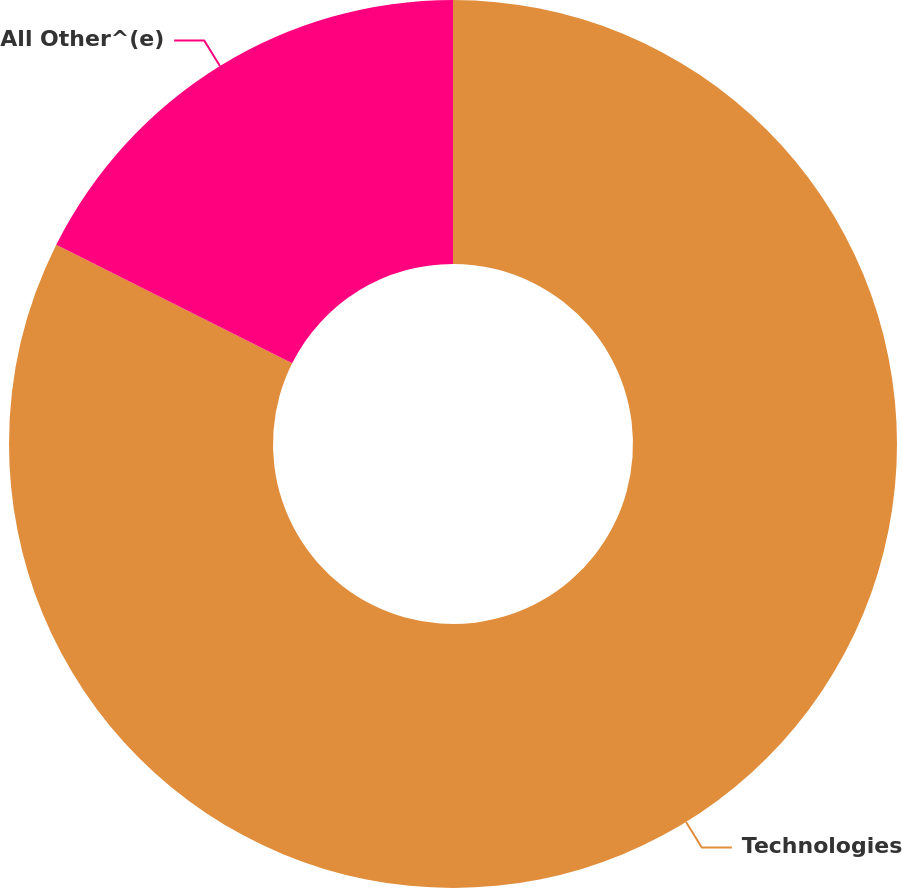Convert chart to OTSL. <chart><loc_0><loc_0><loc_500><loc_500><pie_chart><fcel>Technologies<fcel>All Other^(e)<nl><fcel>82.41%<fcel>17.59%<nl></chart> 